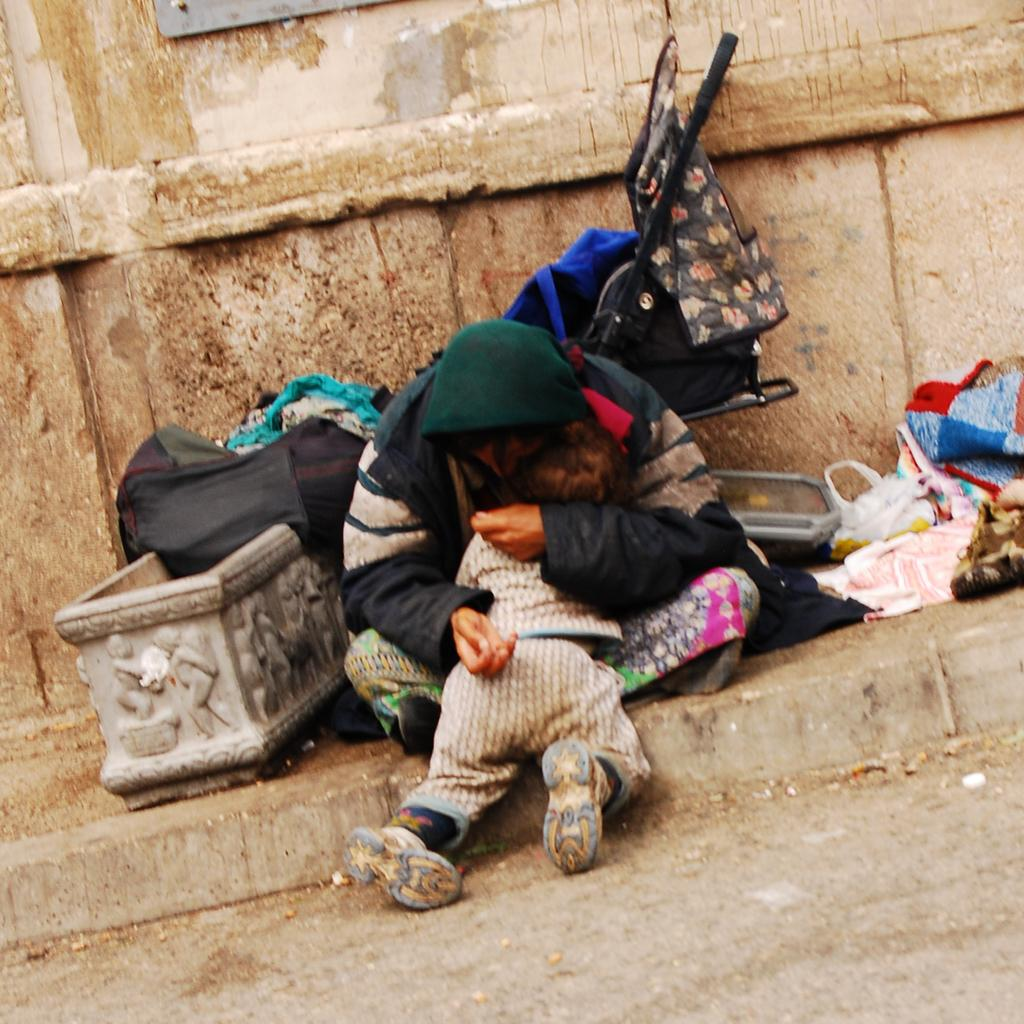What is the person in the image doing? The person is sitting in the image and holding a baby. What else can be seen in the image besides the person and the baby? There are bags and clothes visible behind the person. What is in the background of the image? There is a wall in the background of the image. What type of stitch is being used to hold the baby in the image? There is no stitching involved in holding the baby; the person is simply holding the baby with their arms. Is the person in the image part of the army? There is no indication in the image that the person is part of the army. 